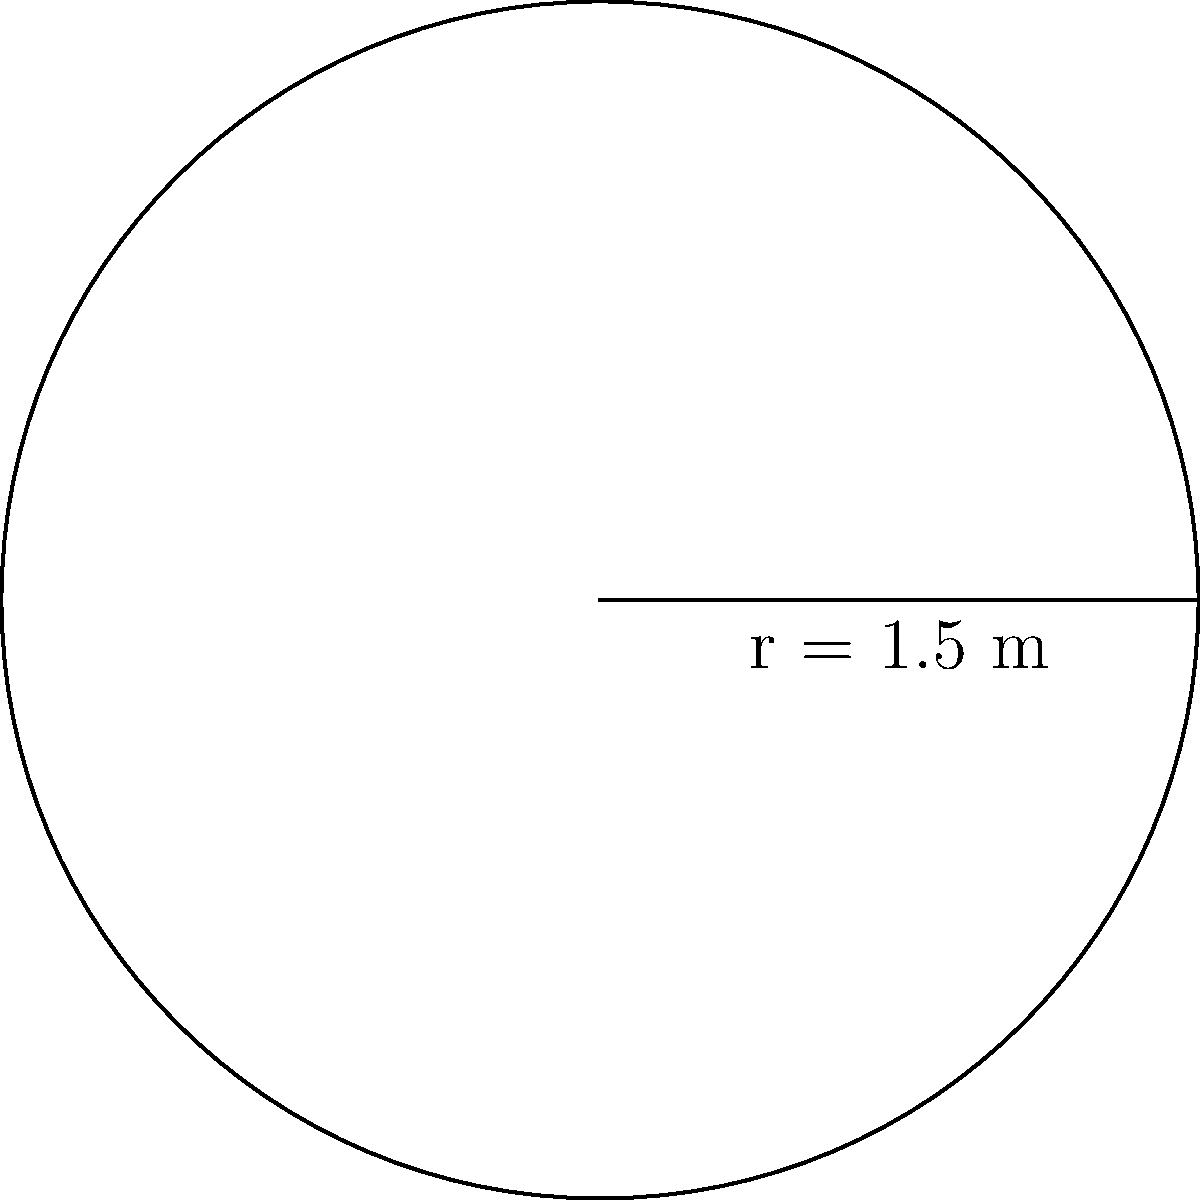You're cleaning a circular outdoor table with a radius of 1.5 meters. What is the surface area of the table top that needs to be cleaned? To find the area of a circular table top, we use the formula:

$$A = \pi r^2$$

Where:
$A$ = area
$\pi$ = pi (approximately 3.14159)
$r$ = radius

Given:
$r = 1.5$ meters

Step 1: Substitute the values into the formula
$$A = \pi (1.5)^2$$

Step 2: Calculate the square of the radius
$$A = \pi (2.25)$$

Step 3: Multiply by pi
$$A = 7.0686 \text{ m}^2$$

Step 4: Round to two decimal places
$$A \approx 7.07 \text{ m}^2$$
Answer: 7.07 m² 